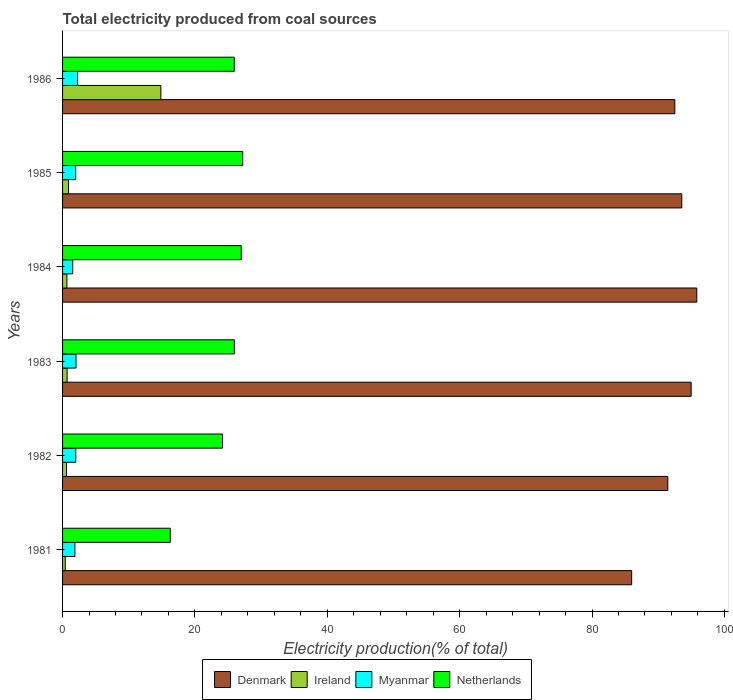How many different coloured bars are there?
Offer a very short reply. 4. Are the number of bars per tick equal to the number of legend labels?
Provide a succinct answer. Yes. Are the number of bars on each tick of the Y-axis equal?
Provide a short and direct response. Yes. How many bars are there on the 4th tick from the top?
Ensure brevity in your answer.  4. How many bars are there on the 5th tick from the bottom?
Offer a terse response. 4. In how many cases, is the number of bars for a given year not equal to the number of legend labels?
Your response must be concise. 0. What is the total electricity produced in Netherlands in 1986?
Make the answer very short. 25.95. Across all years, what is the maximum total electricity produced in Ireland?
Provide a succinct answer. 14.85. Across all years, what is the minimum total electricity produced in Netherlands?
Offer a very short reply. 16.28. In which year was the total electricity produced in Ireland maximum?
Make the answer very short. 1986. In which year was the total electricity produced in Myanmar minimum?
Give a very brief answer. 1984. What is the total total electricity produced in Ireland in the graph?
Offer a terse response. 18.11. What is the difference between the total electricity produced in Ireland in 1981 and that in 1984?
Offer a terse response. -0.25. What is the difference between the total electricity produced in Denmark in 1983 and the total electricity produced in Netherlands in 1982?
Your answer should be very brief. 70.82. What is the average total electricity produced in Ireland per year?
Offer a terse response. 3.02. In the year 1984, what is the difference between the total electricity produced in Denmark and total electricity produced in Netherlands?
Your response must be concise. 68.84. In how many years, is the total electricity produced in Myanmar greater than 4 %?
Ensure brevity in your answer.  0. What is the ratio of the total electricity produced in Ireland in 1981 to that in 1982?
Make the answer very short. 0.68. Is the total electricity produced in Netherlands in 1984 less than that in 1985?
Keep it short and to the point. Yes. Is the difference between the total electricity produced in Denmark in 1982 and 1986 greater than the difference between the total electricity produced in Netherlands in 1982 and 1986?
Ensure brevity in your answer.  Yes. What is the difference between the highest and the second highest total electricity produced in Netherlands?
Your answer should be very brief. 0.22. What is the difference between the highest and the lowest total electricity produced in Netherlands?
Provide a succinct answer. 10.94. Is the sum of the total electricity produced in Ireland in 1981 and 1985 greater than the maximum total electricity produced in Denmark across all years?
Give a very brief answer. No. Is it the case that in every year, the sum of the total electricity produced in Myanmar and total electricity produced in Denmark is greater than the sum of total electricity produced in Ireland and total electricity produced in Netherlands?
Your answer should be very brief. Yes. What does the 2nd bar from the top in 1986 represents?
Give a very brief answer. Myanmar. What does the 2nd bar from the bottom in 1984 represents?
Make the answer very short. Ireland. Is it the case that in every year, the sum of the total electricity produced in Denmark and total electricity produced in Ireland is greater than the total electricity produced in Netherlands?
Ensure brevity in your answer.  Yes. How many bars are there?
Keep it short and to the point. 24. Are all the bars in the graph horizontal?
Give a very brief answer. Yes. How many years are there in the graph?
Keep it short and to the point. 6. What is the difference between two consecutive major ticks on the X-axis?
Give a very brief answer. 20. Does the graph contain any zero values?
Offer a very short reply. No. Does the graph contain grids?
Your response must be concise. No. How are the legend labels stacked?
Offer a terse response. Horizontal. What is the title of the graph?
Offer a terse response. Total electricity produced from coal sources. Does "Eritrea" appear as one of the legend labels in the graph?
Make the answer very short. No. What is the Electricity production(% of total) of Denmark in 1981?
Your response must be concise. 85.99. What is the Electricity production(% of total) in Ireland in 1981?
Ensure brevity in your answer.  0.41. What is the Electricity production(% of total) of Myanmar in 1981?
Your answer should be very brief. 1.86. What is the Electricity production(% of total) in Netherlands in 1981?
Offer a terse response. 16.28. What is the Electricity production(% of total) in Denmark in 1982?
Keep it short and to the point. 91.45. What is the Electricity production(% of total) in Ireland in 1982?
Ensure brevity in your answer.  0.6. What is the Electricity production(% of total) of Myanmar in 1982?
Your response must be concise. 2. What is the Electricity production(% of total) in Netherlands in 1982?
Give a very brief answer. 24.16. What is the Electricity production(% of total) in Denmark in 1983?
Give a very brief answer. 94.98. What is the Electricity production(% of total) in Ireland in 1983?
Provide a short and direct response. 0.69. What is the Electricity production(% of total) in Myanmar in 1983?
Make the answer very short. 2.03. What is the Electricity production(% of total) of Netherlands in 1983?
Make the answer very short. 25.96. What is the Electricity production(% of total) of Denmark in 1984?
Ensure brevity in your answer.  95.83. What is the Electricity production(% of total) in Ireland in 1984?
Your answer should be compact. 0.66. What is the Electricity production(% of total) of Myanmar in 1984?
Give a very brief answer. 1.53. What is the Electricity production(% of total) in Netherlands in 1984?
Offer a very short reply. 27. What is the Electricity production(% of total) in Denmark in 1985?
Offer a terse response. 93.56. What is the Electricity production(% of total) of Ireland in 1985?
Your response must be concise. 0.9. What is the Electricity production(% of total) in Myanmar in 1985?
Your answer should be compact. 1.98. What is the Electricity production(% of total) in Netherlands in 1985?
Provide a succinct answer. 27.22. What is the Electricity production(% of total) of Denmark in 1986?
Offer a very short reply. 92.52. What is the Electricity production(% of total) in Ireland in 1986?
Ensure brevity in your answer.  14.85. What is the Electricity production(% of total) in Myanmar in 1986?
Your answer should be very brief. 2.27. What is the Electricity production(% of total) of Netherlands in 1986?
Make the answer very short. 25.95. Across all years, what is the maximum Electricity production(% of total) of Denmark?
Offer a very short reply. 95.83. Across all years, what is the maximum Electricity production(% of total) of Ireland?
Keep it short and to the point. 14.85. Across all years, what is the maximum Electricity production(% of total) of Myanmar?
Provide a succinct answer. 2.27. Across all years, what is the maximum Electricity production(% of total) in Netherlands?
Your answer should be compact. 27.22. Across all years, what is the minimum Electricity production(% of total) of Denmark?
Make the answer very short. 85.99. Across all years, what is the minimum Electricity production(% of total) in Ireland?
Offer a terse response. 0.41. Across all years, what is the minimum Electricity production(% of total) in Myanmar?
Make the answer very short. 1.53. Across all years, what is the minimum Electricity production(% of total) in Netherlands?
Provide a short and direct response. 16.28. What is the total Electricity production(% of total) of Denmark in the graph?
Give a very brief answer. 554.34. What is the total Electricity production(% of total) in Ireland in the graph?
Your answer should be compact. 18.11. What is the total Electricity production(% of total) in Myanmar in the graph?
Keep it short and to the point. 11.68. What is the total Electricity production(% of total) in Netherlands in the graph?
Give a very brief answer. 146.56. What is the difference between the Electricity production(% of total) in Denmark in 1981 and that in 1982?
Ensure brevity in your answer.  -5.46. What is the difference between the Electricity production(% of total) in Ireland in 1981 and that in 1982?
Offer a very short reply. -0.19. What is the difference between the Electricity production(% of total) in Myanmar in 1981 and that in 1982?
Your response must be concise. -0.13. What is the difference between the Electricity production(% of total) in Netherlands in 1981 and that in 1982?
Your response must be concise. -7.89. What is the difference between the Electricity production(% of total) in Denmark in 1981 and that in 1983?
Ensure brevity in your answer.  -8.99. What is the difference between the Electricity production(% of total) in Ireland in 1981 and that in 1983?
Offer a very short reply. -0.28. What is the difference between the Electricity production(% of total) in Myanmar in 1981 and that in 1983?
Provide a succinct answer. -0.17. What is the difference between the Electricity production(% of total) in Netherlands in 1981 and that in 1983?
Your response must be concise. -9.68. What is the difference between the Electricity production(% of total) of Denmark in 1981 and that in 1984?
Keep it short and to the point. -9.84. What is the difference between the Electricity production(% of total) of Ireland in 1981 and that in 1984?
Provide a short and direct response. -0.25. What is the difference between the Electricity production(% of total) in Myanmar in 1981 and that in 1984?
Provide a succinct answer. 0.33. What is the difference between the Electricity production(% of total) of Netherlands in 1981 and that in 1984?
Keep it short and to the point. -10.72. What is the difference between the Electricity production(% of total) of Denmark in 1981 and that in 1985?
Make the answer very short. -7.57. What is the difference between the Electricity production(% of total) of Ireland in 1981 and that in 1985?
Make the answer very short. -0.49. What is the difference between the Electricity production(% of total) in Myanmar in 1981 and that in 1985?
Keep it short and to the point. -0.12. What is the difference between the Electricity production(% of total) in Netherlands in 1981 and that in 1985?
Offer a very short reply. -10.94. What is the difference between the Electricity production(% of total) of Denmark in 1981 and that in 1986?
Your answer should be compact. -6.52. What is the difference between the Electricity production(% of total) of Ireland in 1981 and that in 1986?
Offer a very short reply. -14.44. What is the difference between the Electricity production(% of total) of Myanmar in 1981 and that in 1986?
Offer a terse response. -0.41. What is the difference between the Electricity production(% of total) in Netherlands in 1981 and that in 1986?
Make the answer very short. -9.67. What is the difference between the Electricity production(% of total) of Denmark in 1982 and that in 1983?
Offer a terse response. -3.53. What is the difference between the Electricity production(% of total) of Ireland in 1982 and that in 1983?
Your response must be concise. -0.09. What is the difference between the Electricity production(% of total) of Myanmar in 1982 and that in 1983?
Keep it short and to the point. -0.03. What is the difference between the Electricity production(% of total) in Netherlands in 1982 and that in 1983?
Provide a short and direct response. -1.8. What is the difference between the Electricity production(% of total) of Denmark in 1982 and that in 1984?
Your response must be concise. -4.38. What is the difference between the Electricity production(% of total) in Ireland in 1982 and that in 1984?
Provide a short and direct response. -0.06. What is the difference between the Electricity production(% of total) of Myanmar in 1982 and that in 1984?
Provide a succinct answer. 0.46. What is the difference between the Electricity production(% of total) in Netherlands in 1982 and that in 1984?
Offer a very short reply. -2.84. What is the difference between the Electricity production(% of total) in Denmark in 1982 and that in 1985?
Offer a very short reply. -2.11. What is the difference between the Electricity production(% of total) in Ireland in 1982 and that in 1985?
Provide a short and direct response. -0.3. What is the difference between the Electricity production(% of total) in Myanmar in 1982 and that in 1985?
Offer a terse response. 0.02. What is the difference between the Electricity production(% of total) of Netherlands in 1982 and that in 1985?
Give a very brief answer. -3.06. What is the difference between the Electricity production(% of total) of Denmark in 1982 and that in 1986?
Offer a very short reply. -1.06. What is the difference between the Electricity production(% of total) in Ireland in 1982 and that in 1986?
Your answer should be very brief. -14.26. What is the difference between the Electricity production(% of total) in Myanmar in 1982 and that in 1986?
Your answer should be compact. -0.27. What is the difference between the Electricity production(% of total) in Netherlands in 1982 and that in 1986?
Give a very brief answer. -1.79. What is the difference between the Electricity production(% of total) in Denmark in 1983 and that in 1984?
Keep it short and to the point. -0.85. What is the difference between the Electricity production(% of total) of Ireland in 1983 and that in 1984?
Ensure brevity in your answer.  0.03. What is the difference between the Electricity production(% of total) of Myanmar in 1983 and that in 1984?
Provide a short and direct response. 0.5. What is the difference between the Electricity production(% of total) of Netherlands in 1983 and that in 1984?
Keep it short and to the point. -1.04. What is the difference between the Electricity production(% of total) in Denmark in 1983 and that in 1985?
Your answer should be very brief. 1.42. What is the difference between the Electricity production(% of total) in Ireland in 1983 and that in 1985?
Provide a short and direct response. -0.22. What is the difference between the Electricity production(% of total) in Myanmar in 1983 and that in 1985?
Provide a short and direct response. 0.05. What is the difference between the Electricity production(% of total) in Netherlands in 1983 and that in 1985?
Provide a short and direct response. -1.26. What is the difference between the Electricity production(% of total) in Denmark in 1983 and that in 1986?
Offer a terse response. 2.47. What is the difference between the Electricity production(% of total) of Ireland in 1983 and that in 1986?
Provide a short and direct response. -14.17. What is the difference between the Electricity production(% of total) of Myanmar in 1983 and that in 1986?
Give a very brief answer. -0.24. What is the difference between the Electricity production(% of total) in Netherlands in 1983 and that in 1986?
Your answer should be compact. 0.01. What is the difference between the Electricity production(% of total) of Denmark in 1984 and that in 1985?
Make the answer very short. 2.27. What is the difference between the Electricity production(% of total) of Ireland in 1984 and that in 1985?
Your response must be concise. -0.24. What is the difference between the Electricity production(% of total) of Myanmar in 1984 and that in 1985?
Give a very brief answer. -0.45. What is the difference between the Electricity production(% of total) in Netherlands in 1984 and that in 1985?
Offer a very short reply. -0.22. What is the difference between the Electricity production(% of total) of Denmark in 1984 and that in 1986?
Your response must be concise. 3.32. What is the difference between the Electricity production(% of total) in Ireland in 1984 and that in 1986?
Make the answer very short. -14.19. What is the difference between the Electricity production(% of total) in Myanmar in 1984 and that in 1986?
Your response must be concise. -0.74. What is the difference between the Electricity production(% of total) of Netherlands in 1984 and that in 1986?
Your response must be concise. 1.05. What is the difference between the Electricity production(% of total) in Denmark in 1985 and that in 1986?
Keep it short and to the point. 1.05. What is the difference between the Electricity production(% of total) in Ireland in 1985 and that in 1986?
Your answer should be very brief. -13.95. What is the difference between the Electricity production(% of total) of Myanmar in 1985 and that in 1986?
Your answer should be very brief. -0.29. What is the difference between the Electricity production(% of total) in Netherlands in 1985 and that in 1986?
Ensure brevity in your answer.  1.27. What is the difference between the Electricity production(% of total) in Denmark in 1981 and the Electricity production(% of total) in Ireland in 1982?
Give a very brief answer. 85.4. What is the difference between the Electricity production(% of total) in Denmark in 1981 and the Electricity production(% of total) in Myanmar in 1982?
Offer a very short reply. 84. What is the difference between the Electricity production(% of total) of Denmark in 1981 and the Electricity production(% of total) of Netherlands in 1982?
Ensure brevity in your answer.  61.83. What is the difference between the Electricity production(% of total) in Ireland in 1981 and the Electricity production(% of total) in Myanmar in 1982?
Your response must be concise. -1.59. What is the difference between the Electricity production(% of total) of Ireland in 1981 and the Electricity production(% of total) of Netherlands in 1982?
Keep it short and to the point. -23.75. What is the difference between the Electricity production(% of total) of Myanmar in 1981 and the Electricity production(% of total) of Netherlands in 1982?
Provide a succinct answer. -22.3. What is the difference between the Electricity production(% of total) in Denmark in 1981 and the Electricity production(% of total) in Ireland in 1983?
Offer a very short reply. 85.31. What is the difference between the Electricity production(% of total) in Denmark in 1981 and the Electricity production(% of total) in Myanmar in 1983?
Make the answer very short. 83.96. What is the difference between the Electricity production(% of total) of Denmark in 1981 and the Electricity production(% of total) of Netherlands in 1983?
Keep it short and to the point. 60.03. What is the difference between the Electricity production(% of total) of Ireland in 1981 and the Electricity production(% of total) of Myanmar in 1983?
Ensure brevity in your answer.  -1.62. What is the difference between the Electricity production(% of total) in Ireland in 1981 and the Electricity production(% of total) in Netherlands in 1983?
Offer a terse response. -25.55. What is the difference between the Electricity production(% of total) in Myanmar in 1981 and the Electricity production(% of total) in Netherlands in 1983?
Your response must be concise. -24.1. What is the difference between the Electricity production(% of total) of Denmark in 1981 and the Electricity production(% of total) of Ireland in 1984?
Give a very brief answer. 85.34. What is the difference between the Electricity production(% of total) of Denmark in 1981 and the Electricity production(% of total) of Myanmar in 1984?
Make the answer very short. 84.46. What is the difference between the Electricity production(% of total) in Denmark in 1981 and the Electricity production(% of total) in Netherlands in 1984?
Your answer should be very brief. 59. What is the difference between the Electricity production(% of total) in Ireland in 1981 and the Electricity production(% of total) in Myanmar in 1984?
Give a very brief answer. -1.13. What is the difference between the Electricity production(% of total) in Ireland in 1981 and the Electricity production(% of total) in Netherlands in 1984?
Your answer should be very brief. -26.59. What is the difference between the Electricity production(% of total) of Myanmar in 1981 and the Electricity production(% of total) of Netherlands in 1984?
Provide a short and direct response. -25.13. What is the difference between the Electricity production(% of total) of Denmark in 1981 and the Electricity production(% of total) of Ireland in 1985?
Provide a short and direct response. 85.09. What is the difference between the Electricity production(% of total) in Denmark in 1981 and the Electricity production(% of total) in Myanmar in 1985?
Keep it short and to the point. 84.01. What is the difference between the Electricity production(% of total) in Denmark in 1981 and the Electricity production(% of total) in Netherlands in 1985?
Give a very brief answer. 58.78. What is the difference between the Electricity production(% of total) in Ireland in 1981 and the Electricity production(% of total) in Myanmar in 1985?
Ensure brevity in your answer.  -1.57. What is the difference between the Electricity production(% of total) in Ireland in 1981 and the Electricity production(% of total) in Netherlands in 1985?
Your answer should be very brief. -26.81. What is the difference between the Electricity production(% of total) of Myanmar in 1981 and the Electricity production(% of total) of Netherlands in 1985?
Offer a terse response. -25.35. What is the difference between the Electricity production(% of total) of Denmark in 1981 and the Electricity production(% of total) of Ireland in 1986?
Provide a succinct answer. 71.14. What is the difference between the Electricity production(% of total) of Denmark in 1981 and the Electricity production(% of total) of Myanmar in 1986?
Your answer should be very brief. 83.72. What is the difference between the Electricity production(% of total) in Denmark in 1981 and the Electricity production(% of total) in Netherlands in 1986?
Keep it short and to the point. 60.04. What is the difference between the Electricity production(% of total) of Ireland in 1981 and the Electricity production(% of total) of Myanmar in 1986?
Offer a terse response. -1.86. What is the difference between the Electricity production(% of total) in Ireland in 1981 and the Electricity production(% of total) in Netherlands in 1986?
Keep it short and to the point. -25.54. What is the difference between the Electricity production(% of total) in Myanmar in 1981 and the Electricity production(% of total) in Netherlands in 1986?
Keep it short and to the point. -24.09. What is the difference between the Electricity production(% of total) of Denmark in 1982 and the Electricity production(% of total) of Ireland in 1983?
Ensure brevity in your answer.  90.77. What is the difference between the Electricity production(% of total) in Denmark in 1982 and the Electricity production(% of total) in Myanmar in 1983?
Your answer should be very brief. 89.42. What is the difference between the Electricity production(% of total) of Denmark in 1982 and the Electricity production(% of total) of Netherlands in 1983?
Your response must be concise. 65.49. What is the difference between the Electricity production(% of total) in Ireland in 1982 and the Electricity production(% of total) in Myanmar in 1983?
Your response must be concise. -1.43. What is the difference between the Electricity production(% of total) of Ireland in 1982 and the Electricity production(% of total) of Netherlands in 1983?
Your answer should be very brief. -25.36. What is the difference between the Electricity production(% of total) in Myanmar in 1982 and the Electricity production(% of total) in Netherlands in 1983?
Provide a short and direct response. -23.96. What is the difference between the Electricity production(% of total) in Denmark in 1982 and the Electricity production(% of total) in Ireland in 1984?
Ensure brevity in your answer.  90.79. What is the difference between the Electricity production(% of total) of Denmark in 1982 and the Electricity production(% of total) of Myanmar in 1984?
Ensure brevity in your answer.  89.92. What is the difference between the Electricity production(% of total) in Denmark in 1982 and the Electricity production(% of total) in Netherlands in 1984?
Offer a terse response. 64.46. What is the difference between the Electricity production(% of total) of Ireland in 1982 and the Electricity production(% of total) of Myanmar in 1984?
Ensure brevity in your answer.  -0.94. What is the difference between the Electricity production(% of total) in Ireland in 1982 and the Electricity production(% of total) in Netherlands in 1984?
Your response must be concise. -26.4. What is the difference between the Electricity production(% of total) in Myanmar in 1982 and the Electricity production(% of total) in Netherlands in 1984?
Provide a short and direct response. -25. What is the difference between the Electricity production(% of total) in Denmark in 1982 and the Electricity production(% of total) in Ireland in 1985?
Make the answer very short. 90.55. What is the difference between the Electricity production(% of total) of Denmark in 1982 and the Electricity production(% of total) of Myanmar in 1985?
Provide a short and direct response. 89.47. What is the difference between the Electricity production(% of total) of Denmark in 1982 and the Electricity production(% of total) of Netherlands in 1985?
Offer a very short reply. 64.23. What is the difference between the Electricity production(% of total) in Ireland in 1982 and the Electricity production(% of total) in Myanmar in 1985?
Provide a short and direct response. -1.38. What is the difference between the Electricity production(% of total) in Ireland in 1982 and the Electricity production(% of total) in Netherlands in 1985?
Your response must be concise. -26.62. What is the difference between the Electricity production(% of total) of Myanmar in 1982 and the Electricity production(% of total) of Netherlands in 1985?
Your answer should be compact. -25.22. What is the difference between the Electricity production(% of total) of Denmark in 1982 and the Electricity production(% of total) of Ireland in 1986?
Give a very brief answer. 76.6. What is the difference between the Electricity production(% of total) in Denmark in 1982 and the Electricity production(% of total) in Myanmar in 1986?
Ensure brevity in your answer.  89.18. What is the difference between the Electricity production(% of total) in Denmark in 1982 and the Electricity production(% of total) in Netherlands in 1986?
Provide a short and direct response. 65.5. What is the difference between the Electricity production(% of total) of Ireland in 1982 and the Electricity production(% of total) of Myanmar in 1986?
Offer a very short reply. -1.67. What is the difference between the Electricity production(% of total) in Ireland in 1982 and the Electricity production(% of total) in Netherlands in 1986?
Your answer should be very brief. -25.35. What is the difference between the Electricity production(% of total) in Myanmar in 1982 and the Electricity production(% of total) in Netherlands in 1986?
Your answer should be compact. -23.95. What is the difference between the Electricity production(% of total) of Denmark in 1983 and the Electricity production(% of total) of Ireland in 1984?
Ensure brevity in your answer.  94.32. What is the difference between the Electricity production(% of total) of Denmark in 1983 and the Electricity production(% of total) of Myanmar in 1984?
Give a very brief answer. 93.45. What is the difference between the Electricity production(% of total) of Denmark in 1983 and the Electricity production(% of total) of Netherlands in 1984?
Ensure brevity in your answer.  67.98. What is the difference between the Electricity production(% of total) of Ireland in 1983 and the Electricity production(% of total) of Myanmar in 1984?
Your response must be concise. -0.85. What is the difference between the Electricity production(% of total) in Ireland in 1983 and the Electricity production(% of total) in Netherlands in 1984?
Offer a very short reply. -26.31. What is the difference between the Electricity production(% of total) in Myanmar in 1983 and the Electricity production(% of total) in Netherlands in 1984?
Offer a very short reply. -24.97. What is the difference between the Electricity production(% of total) in Denmark in 1983 and the Electricity production(% of total) in Ireland in 1985?
Ensure brevity in your answer.  94.08. What is the difference between the Electricity production(% of total) in Denmark in 1983 and the Electricity production(% of total) in Myanmar in 1985?
Your answer should be very brief. 93. What is the difference between the Electricity production(% of total) of Denmark in 1983 and the Electricity production(% of total) of Netherlands in 1985?
Give a very brief answer. 67.76. What is the difference between the Electricity production(% of total) of Ireland in 1983 and the Electricity production(% of total) of Myanmar in 1985?
Make the answer very short. -1.3. What is the difference between the Electricity production(% of total) in Ireland in 1983 and the Electricity production(% of total) in Netherlands in 1985?
Provide a succinct answer. -26.53. What is the difference between the Electricity production(% of total) of Myanmar in 1983 and the Electricity production(% of total) of Netherlands in 1985?
Keep it short and to the point. -25.19. What is the difference between the Electricity production(% of total) in Denmark in 1983 and the Electricity production(% of total) in Ireland in 1986?
Provide a short and direct response. 80.13. What is the difference between the Electricity production(% of total) of Denmark in 1983 and the Electricity production(% of total) of Myanmar in 1986?
Offer a very short reply. 92.71. What is the difference between the Electricity production(% of total) of Denmark in 1983 and the Electricity production(% of total) of Netherlands in 1986?
Keep it short and to the point. 69.03. What is the difference between the Electricity production(% of total) in Ireland in 1983 and the Electricity production(% of total) in Myanmar in 1986?
Keep it short and to the point. -1.59. What is the difference between the Electricity production(% of total) in Ireland in 1983 and the Electricity production(% of total) in Netherlands in 1986?
Provide a short and direct response. -25.26. What is the difference between the Electricity production(% of total) in Myanmar in 1983 and the Electricity production(% of total) in Netherlands in 1986?
Give a very brief answer. -23.92. What is the difference between the Electricity production(% of total) of Denmark in 1984 and the Electricity production(% of total) of Ireland in 1985?
Keep it short and to the point. 94.93. What is the difference between the Electricity production(% of total) of Denmark in 1984 and the Electricity production(% of total) of Myanmar in 1985?
Make the answer very short. 93.85. What is the difference between the Electricity production(% of total) of Denmark in 1984 and the Electricity production(% of total) of Netherlands in 1985?
Provide a short and direct response. 68.61. What is the difference between the Electricity production(% of total) in Ireland in 1984 and the Electricity production(% of total) in Myanmar in 1985?
Offer a terse response. -1.32. What is the difference between the Electricity production(% of total) of Ireland in 1984 and the Electricity production(% of total) of Netherlands in 1985?
Your response must be concise. -26.56. What is the difference between the Electricity production(% of total) of Myanmar in 1984 and the Electricity production(% of total) of Netherlands in 1985?
Give a very brief answer. -25.68. What is the difference between the Electricity production(% of total) of Denmark in 1984 and the Electricity production(% of total) of Ireland in 1986?
Your answer should be very brief. 80.98. What is the difference between the Electricity production(% of total) in Denmark in 1984 and the Electricity production(% of total) in Myanmar in 1986?
Your answer should be very brief. 93.56. What is the difference between the Electricity production(% of total) of Denmark in 1984 and the Electricity production(% of total) of Netherlands in 1986?
Give a very brief answer. 69.88. What is the difference between the Electricity production(% of total) of Ireland in 1984 and the Electricity production(% of total) of Myanmar in 1986?
Give a very brief answer. -1.61. What is the difference between the Electricity production(% of total) of Ireland in 1984 and the Electricity production(% of total) of Netherlands in 1986?
Your response must be concise. -25.29. What is the difference between the Electricity production(% of total) in Myanmar in 1984 and the Electricity production(% of total) in Netherlands in 1986?
Your response must be concise. -24.41. What is the difference between the Electricity production(% of total) in Denmark in 1985 and the Electricity production(% of total) in Ireland in 1986?
Provide a short and direct response. 78.71. What is the difference between the Electricity production(% of total) of Denmark in 1985 and the Electricity production(% of total) of Myanmar in 1986?
Make the answer very short. 91.29. What is the difference between the Electricity production(% of total) of Denmark in 1985 and the Electricity production(% of total) of Netherlands in 1986?
Provide a short and direct response. 67.61. What is the difference between the Electricity production(% of total) in Ireland in 1985 and the Electricity production(% of total) in Myanmar in 1986?
Offer a terse response. -1.37. What is the difference between the Electricity production(% of total) of Ireland in 1985 and the Electricity production(% of total) of Netherlands in 1986?
Give a very brief answer. -25.05. What is the difference between the Electricity production(% of total) of Myanmar in 1985 and the Electricity production(% of total) of Netherlands in 1986?
Keep it short and to the point. -23.97. What is the average Electricity production(% of total) of Denmark per year?
Give a very brief answer. 92.39. What is the average Electricity production(% of total) in Ireland per year?
Your response must be concise. 3.02. What is the average Electricity production(% of total) in Myanmar per year?
Offer a very short reply. 1.95. What is the average Electricity production(% of total) in Netherlands per year?
Keep it short and to the point. 24.43. In the year 1981, what is the difference between the Electricity production(% of total) in Denmark and Electricity production(% of total) in Ireland?
Keep it short and to the point. 85.59. In the year 1981, what is the difference between the Electricity production(% of total) in Denmark and Electricity production(% of total) in Myanmar?
Your answer should be compact. 84.13. In the year 1981, what is the difference between the Electricity production(% of total) in Denmark and Electricity production(% of total) in Netherlands?
Ensure brevity in your answer.  69.72. In the year 1981, what is the difference between the Electricity production(% of total) in Ireland and Electricity production(% of total) in Myanmar?
Provide a succinct answer. -1.46. In the year 1981, what is the difference between the Electricity production(% of total) of Ireland and Electricity production(% of total) of Netherlands?
Your answer should be very brief. -15.87. In the year 1981, what is the difference between the Electricity production(% of total) in Myanmar and Electricity production(% of total) in Netherlands?
Provide a short and direct response. -14.41. In the year 1982, what is the difference between the Electricity production(% of total) of Denmark and Electricity production(% of total) of Ireland?
Offer a very short reply. 90.85. In the year 1982, what is the difference between the Electricity production(% of total) in Denmark and Electricity production(% of total) in Myanmar?
Make the answer very short. 89.45. In the year 1982, what is the difference between the Electricity production(% of total) of Denmark and Electricity production(% of total) of Netherlands?
Your answer should be very brief. 67.29. In the year 1982, what is the difference between the Electricity production(% of total) of Ireland and Electricity production(% of total) of Myanmar?
Keep it short and to the point. -1.4. In the year 1982, what is the difference between the Electricity production(% of total) of Ireland and Electricity production(% of total) of Netherlands?
Your answer should be very brief. -23.56. In the year 1982, what is the difference between the Electricity production(% of total) of Myanmar and Electricity production(% of total) of Netherlands?
Ensure brevity in your answer.  -22.16. In the year 1983, what is the difference between the Electricity production(% of total) in Denmark and Electricity production(% of total) in Ireland?
Provide a succinct answer. 94.3. In the year 1983, what is the difference between the Electricity production(% of total) of Denmark and Electricity production(% of total) of Myanmar?
Offer a terse response. 92.95. In the year 1983, what is the difference between the Electricity production(% of total) of Denmark and Electricity production(% of total) of Netherlands?
Provide a short and direct response. 69.02. In the year 1983, what is the difference between the Electricity production(% of total) of Ireland and Electricity production(% of total) of Myanmar?
Your response must be concise. -1.34. In the year 1983, what is the difference between the Electricity production(% of total) of Ireland and Electricity production(% of total) of Netherlands?
Keep it short and to the point. -25.27. In the year 1983, what is the difference between the Electricity production(% of total) in Myanmar and Electricity production(% of total) in Netherlands?
Your answer should be very brief. -23.93. In the year 1984, what is the difference between the Electricity production(% of total) of Denmark and Electricity production(% of total) of Ireland?
Your answer should be compact. 95.17. In the year 1984, what is the difference between the Electricity production(% of total) of Denmark and Electricity production(% of total) of Myanmar?
Offer a terse response. 94.3. In the year 1984, what is the difference between the Electricity production(% of total) in Denmark and Electricity production(% of total) in Netherlands?
Provide a short and direct response. 68.84. In the year 1984, what is the difference between the Electricity production(% of total) of Ireland and Electricity production(% of total) of Myanmar?
Provide a succinct answer. -0.88. In the year 1984, what is the difference between the Electricity production(% of total) in Ireland and Electricity production(% of total) in Netherlands?
Ensure brevity in your answer.  -26.34. In the year 1984, what is the difference between the Electricity production(% of total) of Myanmar and Electricity production(% of total) of Netherlands?
Your answer should be very brief. -25.46. In the year 1985, what is the difference between the Electricity production(% of total) in Denmark and Electricity production(% of total) in Ireland?
Ensure brevity in your answer.  92.66. In the year 1985, what is the difference between the Electricity production(% of total) in Denmark and Electricity production(% of total) in Myanmar?
Ensure brevity in your answer.  91.58. In the year 1985, what is the difference between the Electricity production(% of total) of Denmark and Electricity production(% of total) of Netherlands?
Offer a very short reply. 66.34. In the year 1985, what is the difference between the Electricity production(% of total) in Ireland and Electricity production(% of total) in Myanmar?
Your response must be concise. -1.08. In the year 1985, what is the difference between the Electricity production(% of total) of Ireland and Electricity production(% of total) of Netherlands?
Give a very brief answer. -26.32. In the year 1985, what is the difference between the Electricity production(% of total) of Myanmar and Electricity production(% of total) of Netherlands?
Make the answer very short. -25.24. In the year 1986, what is the difference between the Electricity production(% of total) in Denmark and Electricity production(% of total) in Ireland?
Your answer should be compact. 77.66. In the year 1986, what is the difference between the Electricity production(% of total) in Denmark and Electricity production(% of total) in Myanmar?
Offer a very short reply. 90.24. In the year 1986, what is the difference between the Electricity production(% of total) in Denmark and Electricity production(% of total) in Netherlands?
Keep it short and to the point. 66.57. In the year 1986, what is the difference between the Electricity production(% of total) in Ireland and Electricity production(% of total) in Myanmar?
Your response must be concise. 12.58. In the year 1986, what is the difference between the Electricity production(% of total) in Ireland and Electricity production(% of total) in Netherlands?
Offer a very short reply. -11.1. In the year 1986, what is the difference between the Electricity production(% of total) in Myanmar and Electricity production(% of total) in Netherlands?
Offer a terse response. -23.68. What is the ratio of the Electricity production(% of total) of Denmark in 1981 to that in 1982?
Give a very brief answer. 0.94. What is the ratio of the Electricity production(% of total) of Ireland in 1981 to that in 1982?
Make the answer very short. 0.68. What is the ratio of the Electricity production(% of total) of Myanmar in 1981 to that in 1982?
Make the answer very short. 0.93. What is the ratio of the Electricity production(% of total) in Netherlands in 1981 to that in 1982?
Make the answer very short. 0.67. What is the ratio of the Electricity production(% of total) of Denmark in 1981 to that in 1983?
Ensure brevity in your answer.  0.91. What is the ratio of the Electricity production(% of total) in Ireland in 1981 to that in 1983?
Offer a terse response. 0.6. What is the ratio of the Electricity production(% of total) in Myanmar in 1981 to that in 1983?
Provide a short and direct response. 0.92. What is the ratio of the Electricity production(% of total) of Netherlands in 1981 to that in 1983?
Offer a very short reply. 0.63. What is the ratio of the Electricity production(% of total) of Denmark in 1981 to that in 1984?
Your answer should be compact. 0.9. What is the ratio of the Electricity production(% of total) in Ireland in 1981 to that in 1984?
Give a very brief answer. 0.62. What is the ratio of the Electricity production(% of total) in Myanmar in 1981 to that in 1984?
Your answer should be compact. 1.21. What is the ratio of the Electricity production(% of total) in Netherlands in 1981 to that in 1984?
Provide a succinct answer. 0.6. What is the ratio of the Electricity production(% of total) of Denmark in 1981 to that in 1985?
Provide a short and direct response. 0.92. What is the ratio of the Electricity production(% of total) of Ireland in 1981 to that in 1985?
Offer a very short reply. 0.45. What is the ratio of the Electricity production(% of total) of Myanmar in 1981 to that in 1985?
Make the answer very short. 0.94. What is the ratio of the Electricity production(% of total) in Netherlands in 1981 to that in 1985?
Your answer should be compact. 0.6. What is the ratio of the Electricity production(% of total) of Denmark in 1981 to that in 1986?
Offer a very short reply. 0.93. What is the ratio of the Electricity production(% of total) of Ireland in 1981 to that in 1986?
Offer a very short reply. 0.03. What is the ratio of the Electricity production(% of total) in Myanmar in 1981 to that in 1986?
Keep it short and to the point. 0.82. What is the ratio of the Electricity production(% of total) of Netherlands in 1981 to that in 1986?
Offer a terse response. 0.63. What is the ratio of the Electricity production(% of total) of Denmark in 1982 to that in 1983?
Your response must be concise. 0.96. What is the ratio of the Electricity production(% of total) in Ireland in 1982 to that in 1983?
Provide a short and direct response. 0.87. What is the ratio of the Electricity production(% of total) of Netherlands in 1982 to that in 1983?
Your response must be concise. 0.93. What is the ratio of the Electricity production(% of total) of Denmark in 1982 to that in 1984?
Offer a very short reply. 0.95. What is the ratio of the Electricity production(% of total) of Ireland in 1982 to that in 1984?
Keep it short and to the point. 0.91. What is the ratio of the Electricity production(% of total) of Myanmar in 1982 to that in 1984?
Give a very brief answer. 1.3. What is the ratio of the Electricity production(% of total) in Netherlands in 1982 to that in 1984?
Offer a very short reply. 0.9. What is the ratio of the Electricity production(% of total) of Denmark in 1982 to that in 1985?
Provide a succinct answer. 0.98. What is the ratio of the Electricity production(% of total) in Ireland in 1982 to that in 1985?
Your response must be concise. 0.66. What is the ratio of the Electricity production(% of total) of Myanmar in 1982 to that in 1985?
Your answer should be very brief. 1.01. What is the ratio of the Electricity production(% of total) of Netherlands in 1982 to that in 1985?
Offer a terse response. 0.89. What is the ratio of the Electricity production(% of total) of Ireland in 1982 to that in 1986?
Your response must be concise. 0.04. What is the ratio of the Electricity production(% of total) in Myanmar in 1982 to that in 1986?
Ensure brevity in your answer.  0.88. What is the ratio of the Electricity production(% of total) in Netherlands in 1982 to that in 1986?
Give a very brief answer. 0.93. What is the ratio of the Electricity production(% of total) of Ireland in 1983 to that in 1984?
Your response must be concise. 1.04. What is the ratio of the Electricity production(% of total) in Myanmar in 1983 to that in 1984?
Make the answer very short. 1.32. What is the ratio of the Electricity production(% of total) of Netherlands in 1983 to that in 1984?
Provide a short and direct response. 0.96. What is the ratio of the Electricity production(% of total) in Denmark in 1983 to that in 1985?
Your answer should be very brief. 1.02. What is the ratio of the Electricity production(% of total) of Ireland in 1983 to that in 1985?
Keep it short and to the point. 0.76. What is the ratio of the Electricity production(% of total) of Myanmar in 1983 to that in 1985?
Offer a very short reply. 1.02. What is the ratio of the Electricity production(% of total) of Netherlands in 1983 to that in 1985?
Keep it short and to the point. 0.95. What is the ratio of the Electricity production(% of total) in Denmark in 1983 to that in 1986?
Offer a terse response. 1.03. What is the ratio of the Electricity production(% of total) of Ireland in 1983 to that in 1986?
Your response must be concise. 0.05. What is the ratio of the Electricity production(% of total) of Myanmar in 1983 to that in 1986?
Provide a short and direct response. 0.89. What is the ratio of the Electricity production(% of total) in Netherlands in 1983 to that in 1986?
Give a very brief answer. 1. What is the ratio of the Electricity production(% of total) of Denmark in 1984 to that in 1985?
Your answer should be compact. 1.02. What is the ratio of the Electricity production(% of total) of Ireland in 1984 to that in 1985?
Make the answer very short. 0.73. What is the ratio of the Electricity production(% of total) of Myanmar in 1984 to that in 1985?
Your answer should be very brief. 0.77. What is the ratio of the Electricity production(% of total) in Denmark in 1984 to that in 1986?
Your answer should be very brief. 1.04. What is the ratio of the Electricity production(% of total) in Ireland in 1984 to that in 1986?
Your answer should be compact. 0.04. What is the ratio of the Electricity production(% of total) of Myanmar in 1984 to that in 1986?
Provide a short and direct response. 0.68. What is the ratio of the Electricity production(% of total) of Netherlands in 1984 to that in 1986?
Your answer should be very brief. 1.04. What is the ratio of the Electricity production(% of total) of Denmark in 1985 to that in 1986?
Provide a short and direct response. 1.01. What is the ratio of the Electricity production(% of total) in Ireland in 1985 to that in 1986?
Provide a short and direct response. 0.06. What is the ratio of the Electricity production(% of total) of Myanmar in 1985 to that in 1986?
Your answer should be very brief. 0.87. What is the ratio of the Electricity production(% of total) of Netherlands in 1985 to that in 1986?
Provide a succinct answer. 1.05. What is the difference between the highest and the second highest Electricity production(% of total) of Denmark?
Offer a very short reply. 0.85. What is the difference between the highest and the second highest Electricity production(% of total) of Ireland?
Ensure brevity in your answer.  13.95. What is the difference between the highest and the second highest Electricity production(% of total) in Myanmar?
Keep it short and to the point. 0.24. What is the difference between the highest and the second highest Electricity production(% of total) of Netherlands?
Your answer should be very brief. 0.22. What is the difference between the highest and the lowest Electricity production(% of total) in Denmark?
Keep it short and to the point. 9.84. What is the difference between the highest and the lowest Electricity production(% of total) in Ireland?
Offer a very short reply. 14.44. What is the difference between the highest and the lowest Electricity production(% of total) of Myanmar?
Make the answer very short. 0.74. What is the difference between the highest and the lowest Electricity production(% of total) of Netherlands?
Keep it short and to the point. 10.94. 